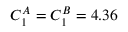Convert formula to latex. <formula><loc_0><loc_0><loc_500><loc_500>C _ { 1 } ^ { A } = C _ { 1 } ^ { B } = 4 . 3 6</formula> 